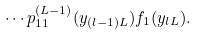Convert formula to latex. <formula><loc_0><loc_0><loc_500><loc_500>\cdots p ^ { ( L - 1 ) } _ { 1 1 } ( y _ { ( l - 1 ) L } ) f _ { 1 } ( y _ { l L } ) .</formula> 